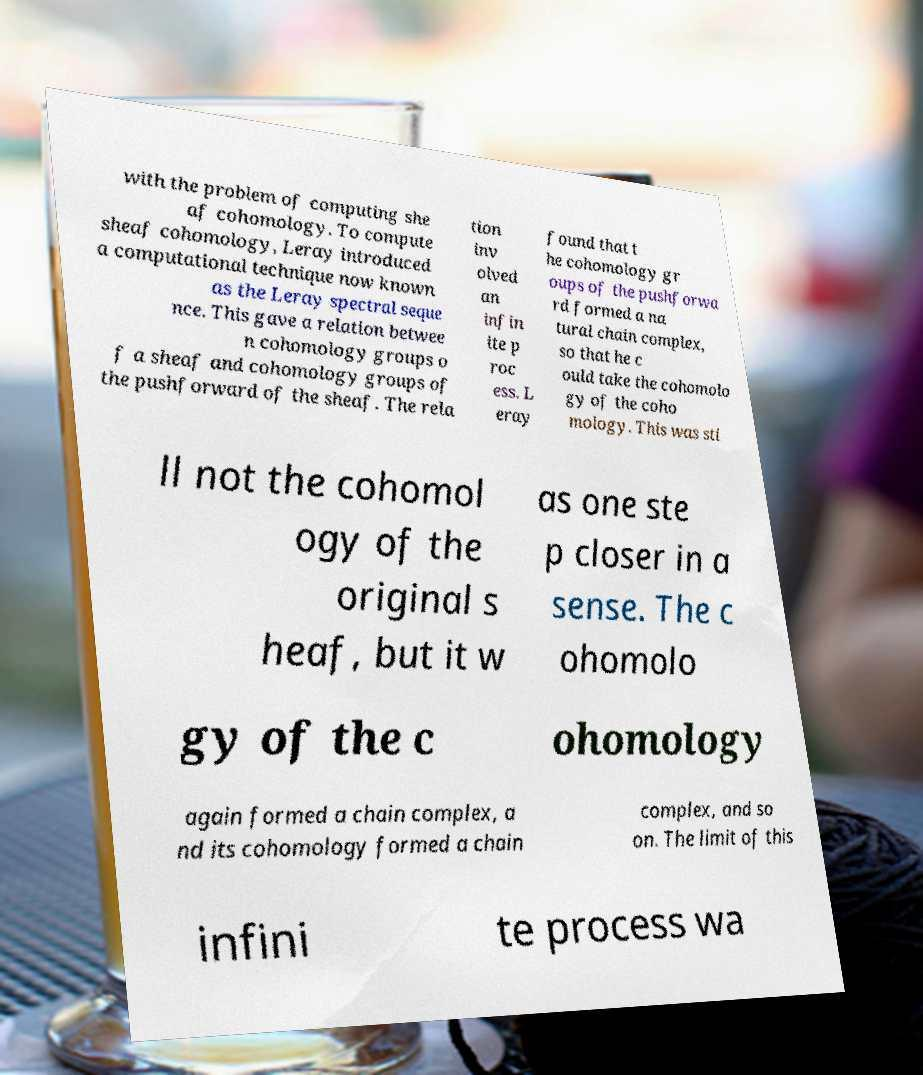What messages or text are displayed in this image? I need them in a readable, typed format. with the problem of computing she af cohomology. To compute sheaf cohomology, Leray introduced a computational technique now known as the Leray spectral seque nce. This gave a relation betwee n cohomology groups o f a sheaf and cohomology groups of the pushforward of the sheaf. The rela tion inv olved an infin ite p roc ess. L eray found that t he cohomology gr oups of the pushforwa rd formed a na tural chain complex, so that he c ould take the cohomolo gy of the coho mology. This was sti ll not the cohomol ogy of the original s heaf, but it w as one ste p closer in a sense. The c ohomolo gy of the c ohomology again formed a chain complex, a nd its cohomology formed a chain complex, and so on. The limit of this infini te process wa 